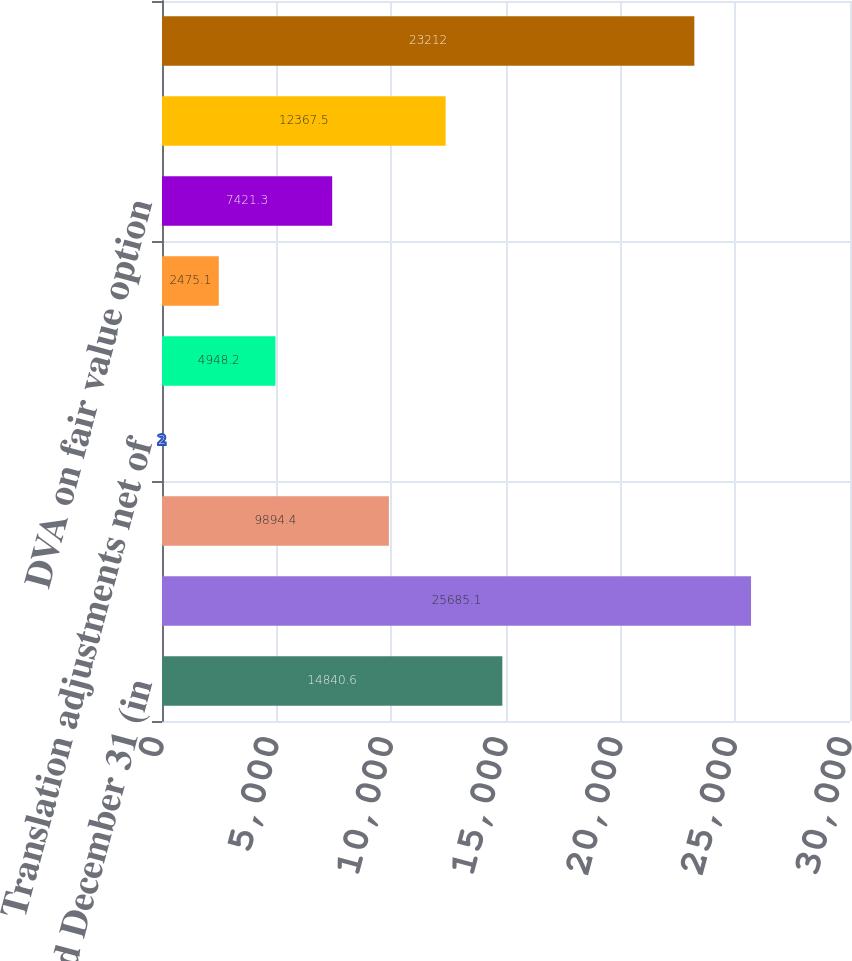Convert chart. <chart><loc_0><loc_0><loc_500><loc_500><bar_chart><fcel>Year ended December 31 (in<fcel>Net income<fcel>Unrealized gains/(losses) on<fcel>Translation adjustments net of<fcel>Cash flow hedges<fcel>Defined benefit pension and<fcel>DVA on fair value option<fcel>Total other comprehensive<fcel>Comprehensive income<nl><fcel>14840.6<fcel>25685.1<fcel>9894.4<fcel>2<fcel>4948.2<fcel>2475.1<fcel>7421.3<fcel>12367.5<fcel>23212<nl></chart> 